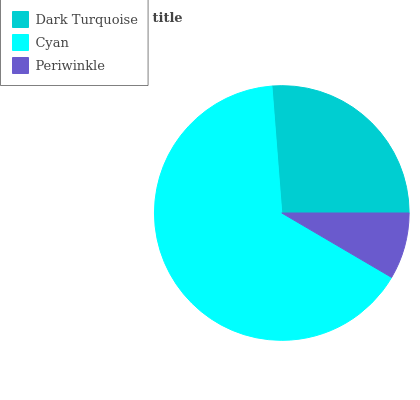Is Periwinkle the minimum?
Answer yes or no. Yes. Is Cyan the maximum?
Answer yes or no. Yes. Is Cyan the minimum?
Answer yes or no. No. Is Periwinkle the maximum?
Answer yes or no. No. Is Cyan greater than Periwinkle?
Answer yes or no. Yes. Is Periwinkle less than Cyan?
Answer yes or no. Yes. Is Periwinkle greater than Cyan?
Answer yes or no. No. Is Cyan less than Periwinkle?
Answer yes or no. No. Is Dark Turquoise the high median?
Answer yes or no. Yes. Is Dark Turquoise the low median?
Answer yes or no. Yes. Is Cyan the high median?
Answer yes or no. No. Is Cyan the low median?
Answer yes or no. No. 